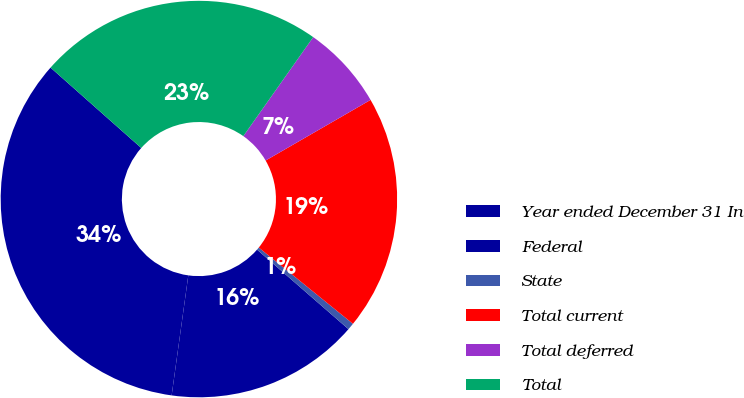Convert chart. <chart><loc_0><loc_0><loc_500><loc_500><pie_chart><fcel>Year ended December 31 In<fcel>Federal<fcel>State<fcel>Total current<fcel>Total deferred<fcel>Total<nl><fcel>34.34%<fcel>15.8%<fcel>0.56%<fcel>19.17%<fcel>6.88%<fcel>23.24%<nl></chart> 